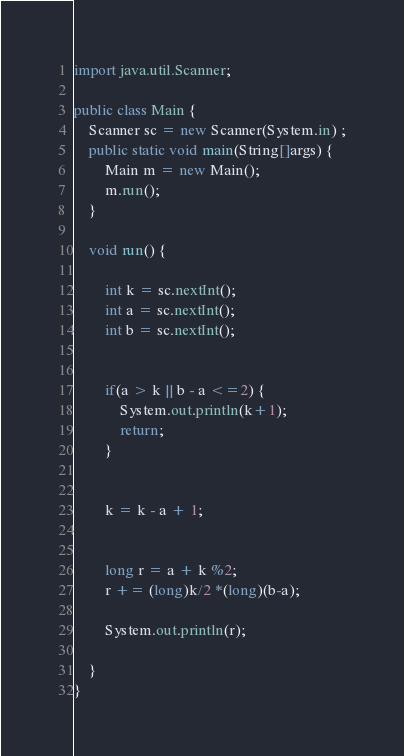<code> <loc_0><loc_0><loc_500><loc_500><_Java_>import java.util.Scanner;

public class Main {
	Scanner sc = new Scanner(System.in) ;
	public static void main(String[]args) {
		Main m = new Main();
		m.run();
	}
	
	void run() {
		
		int k = sc.nextInt();
		int a = sc.nextInt();
		int b = sc.nextInt();
		
		
		if(a > k || b - a <=2) {
			System.out.println(k+1);
			return;
		}
		
		
		k = k - a + 1;
		
		
		long r = a + k %2;
		r += (long)k/2 *(long)(b-a);
		
		System.out.println(r);
		
	}
}
</code> 